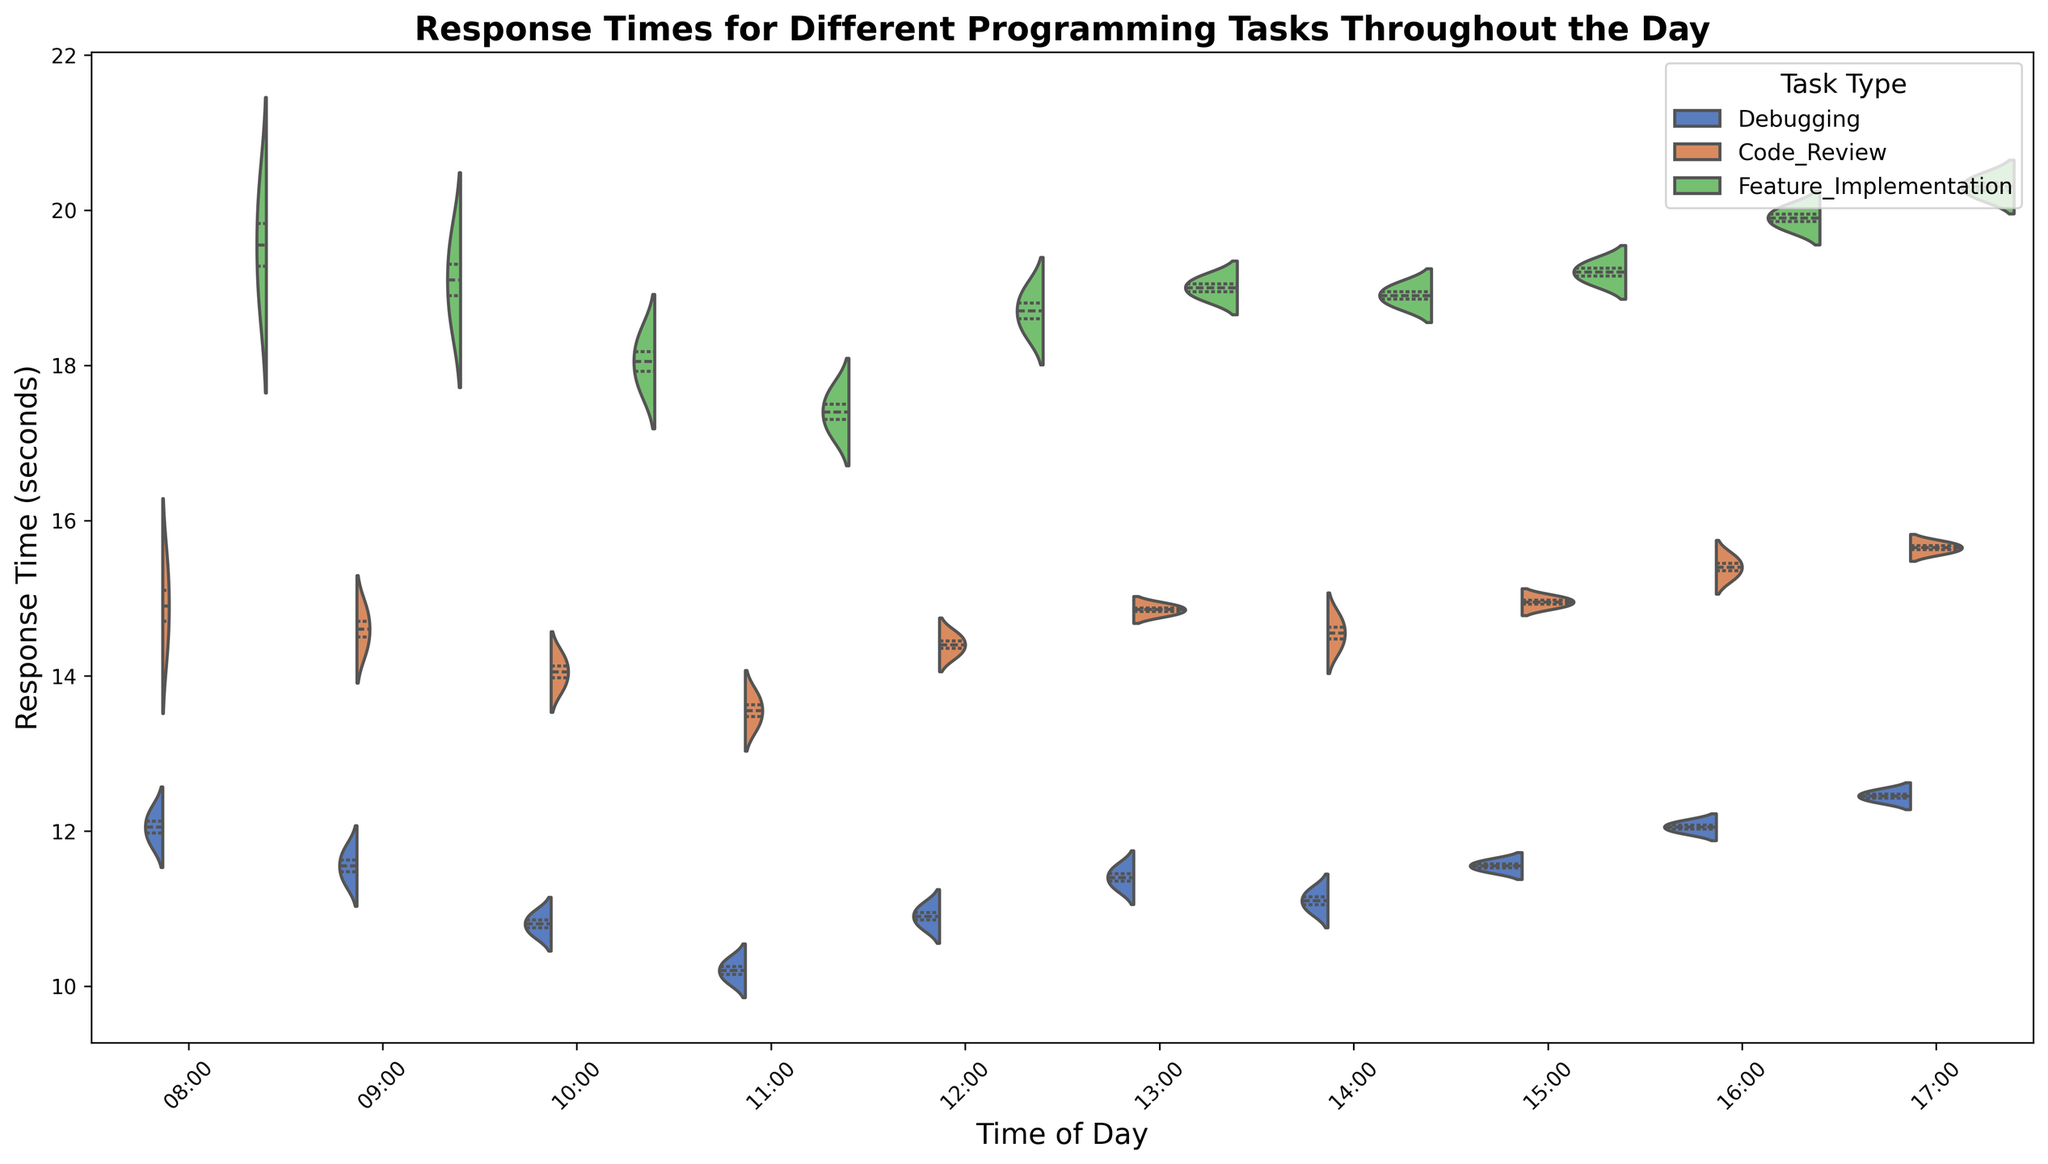What time of day has the lowest median response time for debugging? To find the lowest median response time for debugging, look for the shortest median line segment within the green violins that represent "Debugging" across different times of the day. The lowest median line is found at 11:00.
Answer: 11:00 Which task type shows the highest median response time overall? To find the task type with the highest median response time overall, compare the central white lines across all violins for each task type. The task type "Feature Implementation" (represented in blue) generally has the highest median lines compared to the other types.
Answer: Feature Implementation How does the response time for code reviews at 08:00 compare to 17:00? To compare the response times for code reviews at 08:00 and 17:00, locate the corresponding violins. At 08:00, the median is lower compared to 17:00, where the median line is higher. This suggests response times are generally faster in the morning compared to the evening for code reviews.
Answer: Faster at 08:00 Is there a noticeable trend in response times for debugging tasks throughout the day? To identify any trend, observe the median lines (white lines) within green violins from 08:00 to 17:00. The medians appear to decrease gradually until around 11:00, and then start increasing towards the later part of the day. This suggests an initial improvement in response times, followed by a decline.
Answer: Initial improvement, then decline What is the range of the response time for feature implementation at 12:00? To find the range, observe the blue violin at 12:00. The widest part of the violin gives the range. The bottom quartile is around 18 seconds and the top quartile is approximately 19 seconds, giving a range of about 1 second.
Answer: 1 second Which times of day show a similar median response time across all task types? To identify similar medians across all task types, compare the white median lines within each violin at different times. At 14:00, all medians for "Debugging," "Code Review," and "Feature Implementation" are very close to each other.
Answer: 14:00 Does the variability in response time for debugging increase or decrease towards the end of the day? To determine variability, observe the spread of the green violins over time. The violins for "Debugging" show reduced spread from 08:00 towards 11:00, then start to widen again as time moves to 17:00, indicating increasing variability towards the end of the day.
Answer: Increase Which task type experiences the greatest variability in response time overall? To find the greatest variability, look at the overall width of violins. The blue violins for "Feature Implementation" appear wider, indicating greater variability in response times compared to "Debugging" and "Code Review".
Answer: Feature Implementation Are there any times of day where the response times for two task types appear almost identical? To spot similar response times, compare widths and medians of violins. At 15:00, "Debugging" and "Code Review" have very similar median lines and overall distribution.
Answer: 15:00 